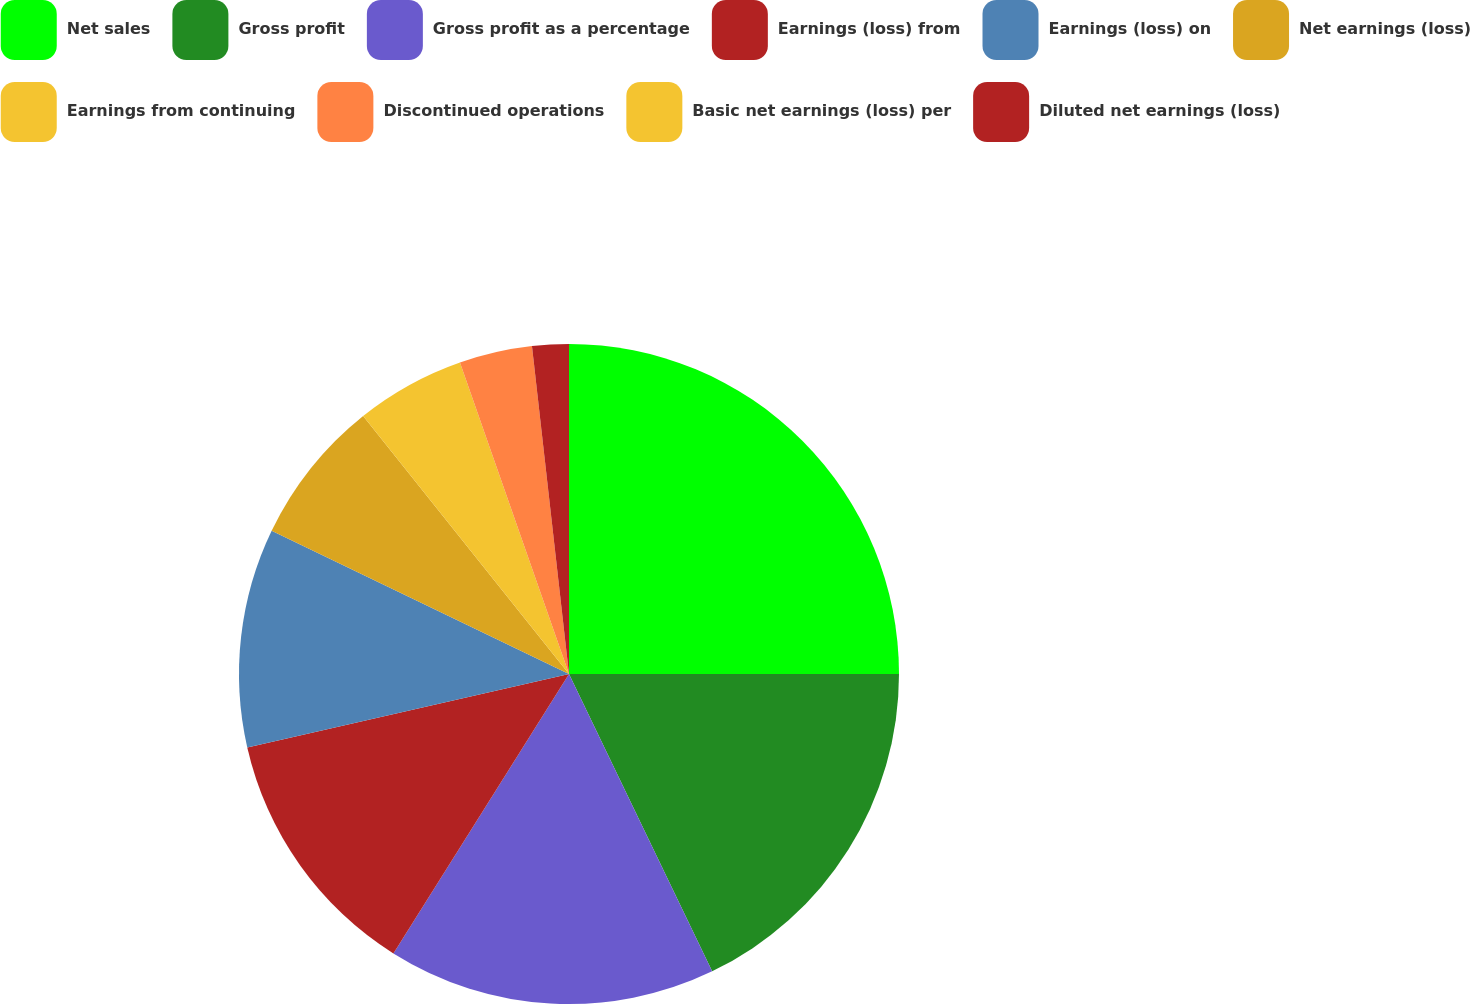<chart> <loc_0><loc_0><loc_500><loc_500><pie_chart><fcel>Net sales<fcel>Gross profit<fcel>Gross profit as a percentage<fcel>Earnings (loss) from<fcel>Earnings (loss) on<fcel>Net earnings (loss)<fcel>Earnings from continuing<fcel>Discontinued operations<fcel>Basic net earnings (loss) per<fcel>Diluted net earnings (loss)<nl><fcel>25.0%<fcel>17.86%<fcel>16.07%<fcel>12.5%<fcel>10.71%<fcel>7.14%<fcel>5.36%<fcel>3.57%<fcel>0.0%<fcel>1.79%<nl></chart> 